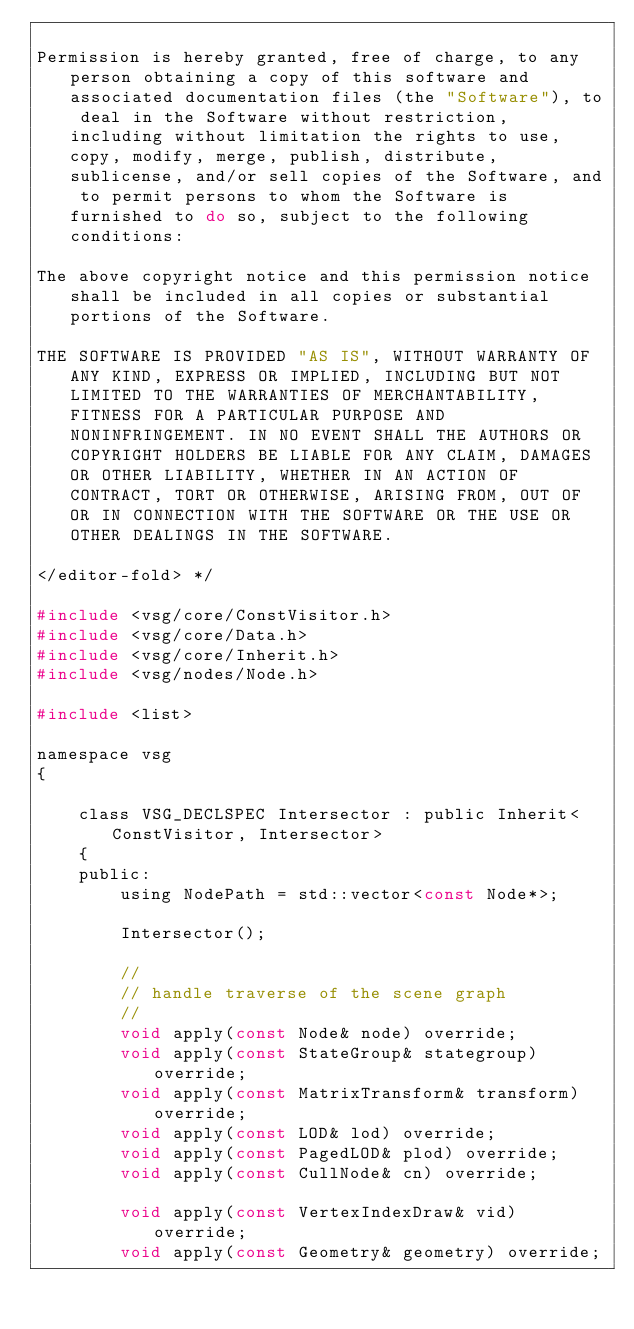Convert code to text. <code><loc_0><loc_0><loc_500><loc_500><_C_>
Permission is hereby granted, free of charge, to any person obtaining a copy of this software and associated documentation files (the "Software"), to deal in the Software without restriction, including without limitation the rights to use, copy, modify, merge, publish, distribute, sublicense, and/or sell copies of the Software, and to permit persons to whom the Software is furnished to do so, subject to the following conditions:

The above copyright notice and this permission notice shall be included in all copies or substantial portions of the Software.

THE SOFTWARE IS PROVIDED "AS IS", WITHOUT WARRANTY OF ANY KIND, EXPRESS OR IMPLIED, INCLUDING BUT NOT LIMITED TO THE WARRANTIES OF MERCHANTABILITY, FITNESS FOR A PARTICULAR PURPOSE AND NONINFRINGEMENT. IN NO EVENT SHALL THE AUTHORS OR COPYRIGHT HOLDERS BE LIABLE FOR ANY CLAIM, DAMAGES OR OTHER LIABILITY, WHETHER IN AN ACTION OF CONTRACT, TORT OR OTHERWISE, ARISING FROM, OUT OF OR IN CONNECTION WITH THE SOFTWARE OR THE USE OR OTHER DEALINGS IN THE SOFTWARE.

</editor-fold> */

#include <vsg/core/ConstVisitor.h>
#include <vsg/core/Data.h>
#include <vsg/core/Inherit.h>
#include <vsg/nodes/Node.h>

#include <list>

namespace vsg
{

    class VSG_DECLSPEC Intersector : public Inherit<ConstVisitor, Intersector>
    {
    public:
        using NodePath = std::vector<const Node*>;

        Intersector();

        //
        // handle traverse of the scene graph
        //
        void apply(const Node& node) override;
        void apply(const StateGroup& stategroup) override;
        void apply(const MatrixTransform& transform) override;
        void apply(const LOD& lod) override;
        void apply(const PagedLOD& plod) override;
        void apply(const CullNode& cn) override;

        void apply(const VertexIndexDraw& vid) override;
        void apply(const Geometry& geometry) override;
</code> 